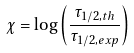Convert formula to latex. <formula><loc_0><loc_0><loc_500><loc_500>\chi = \log \left ( \frac { \tau _ { 1 / 2 , t h } } { \tau _ { 1 / 2 , e x p } } \right )</formula> 